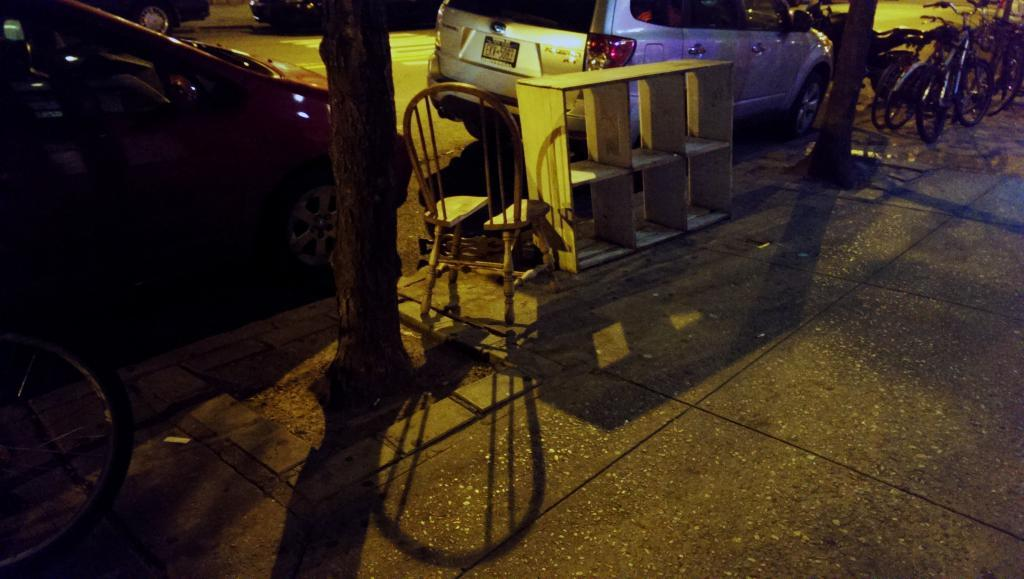What can be seen on the road in the image? There are vehicles on the road in the image. What type of furniture is in the image? There is a chair in the image. What structure is present in the image? There is a stand in the image. What natural elements are visible in the image? Tree trunks are present in the image. What mode of transportation can be seen in the image? Bicycles are visible in the image. What type of protest is taking place in the image? There is no protest present in the image; it features vehicles, a chair, a stand, tree trunks, and bicycles. Can you tell me how many people are running in the image? There are no people running in the image. 